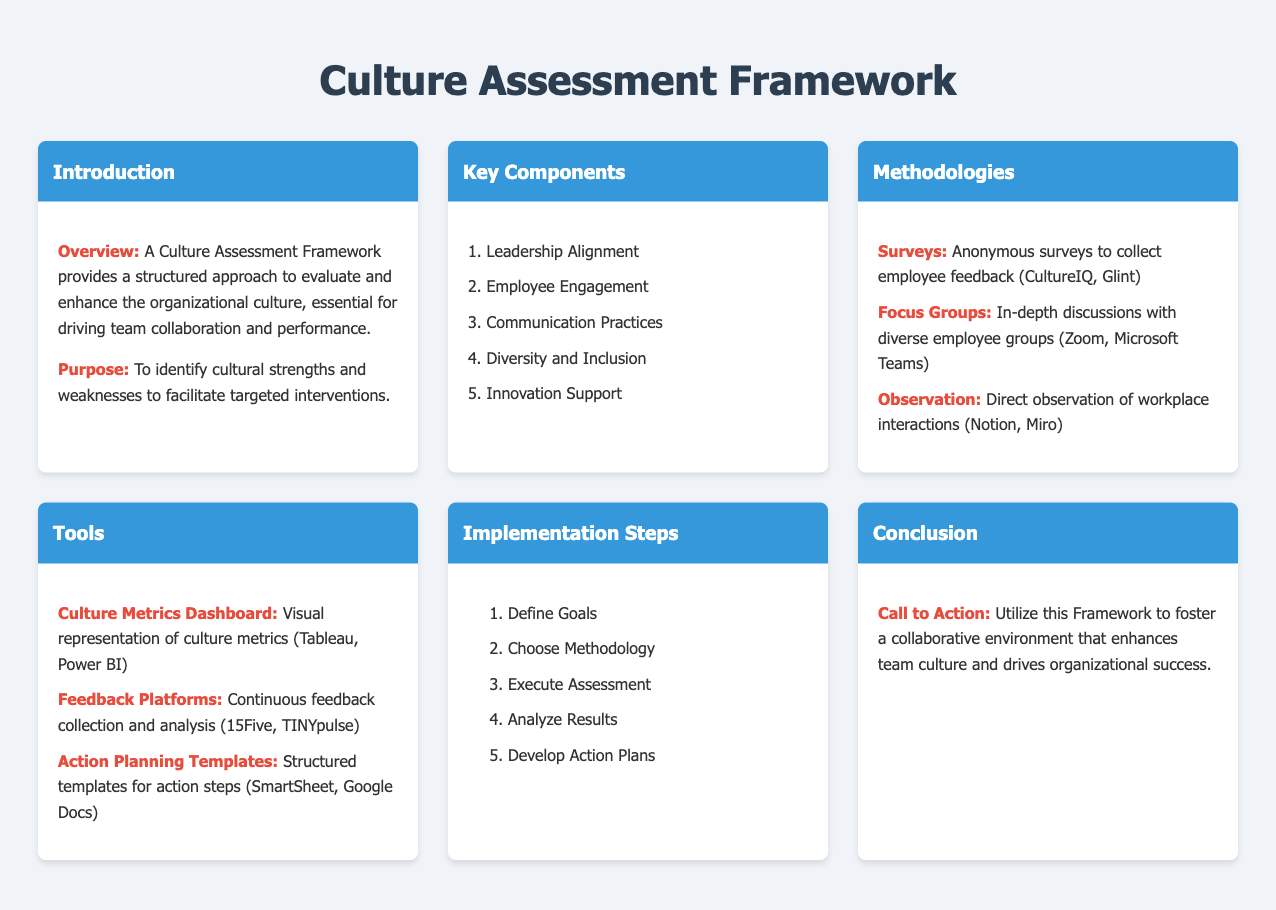What is the purpose of the Culture Assessment Framework? The purpose is to identify cultural strengths and weaknesses to facilitate targeted interventions.
Answer: To identify cultural strengths and weaknesses What are the methodologies mentioned in the document? The methodologies include surveys, focus groups, and observation.
Answer: Surveys, focus groups, and observation How many key components are listed in the document? The document lists five key components of the Culture Assessment Framework.
Answer: Five Which tool is described as a visual representation of culture metrics? The Culture Metrics Dashboard is defined as a visual representation of culture metrics.
Answer: Culture Metrics Dashboard What is the first step in the implementation process? The first step is to define goals as part of the implementation process.
Answer: Define Goals What type of assessment does the document encourage for employee feedback? The document encourages the use of anonymous surveys for collecting employee feedback.
Answer: Anonymous surveys What is the call to action described in the conclusion? The call to action is to utilize this Framework to foster a collaborative environment.
Answer: Utilize this Framework How many items are listed under key components? There are five items listed under the key components.
Answer: Five Which platform is noted for continuous feedback collection? The document mentions 15Five as a platform for continuous feedback collection.
Answer: 15Five 